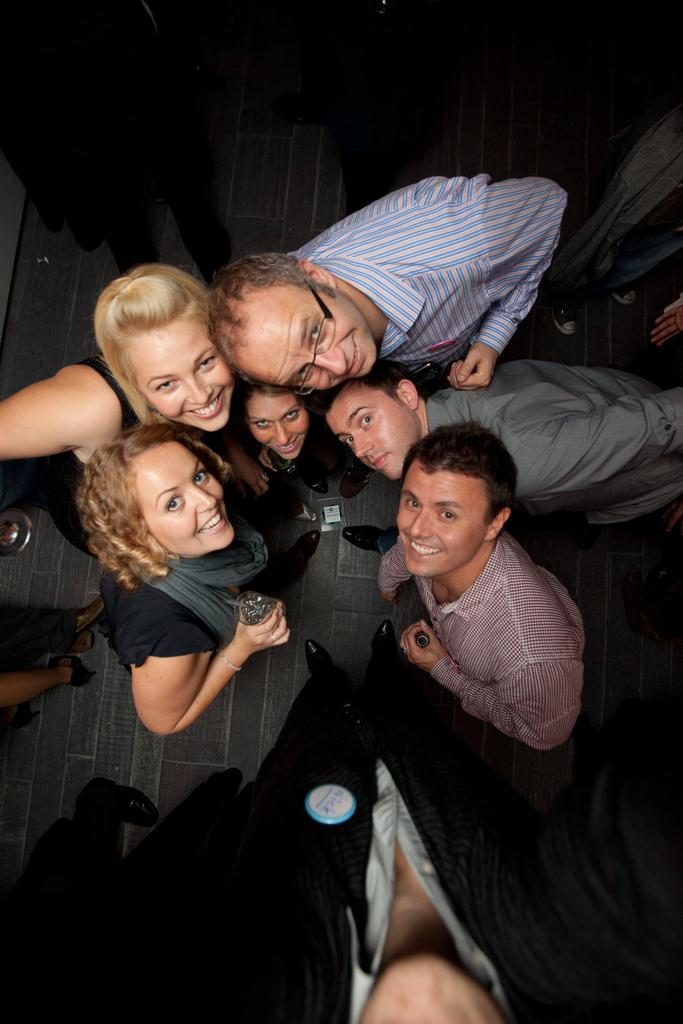What is happening in the image? There are people standing in the image. What is the surface on which the people are standing? The people are standing on the floor. What objects are the people holding in their hands? The people are holding glasses and bottles. What type of belief is being expressed by the people holding scissors in the image? There are no scissors present in the image, so it is not possible to determine what belief might be expressed. 